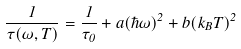Convert formula to latex. <formula><loc_0><loc_0><loc_500><loc_500>\frac { 1 } { \tau ( \omega , T ) } = \frac { 1 } { \tau _ { 0 } } + a ( \hbar { \omega } ) ^ { 2 } + b ( k _ { B } T ) ^ { 2 }</formula> 